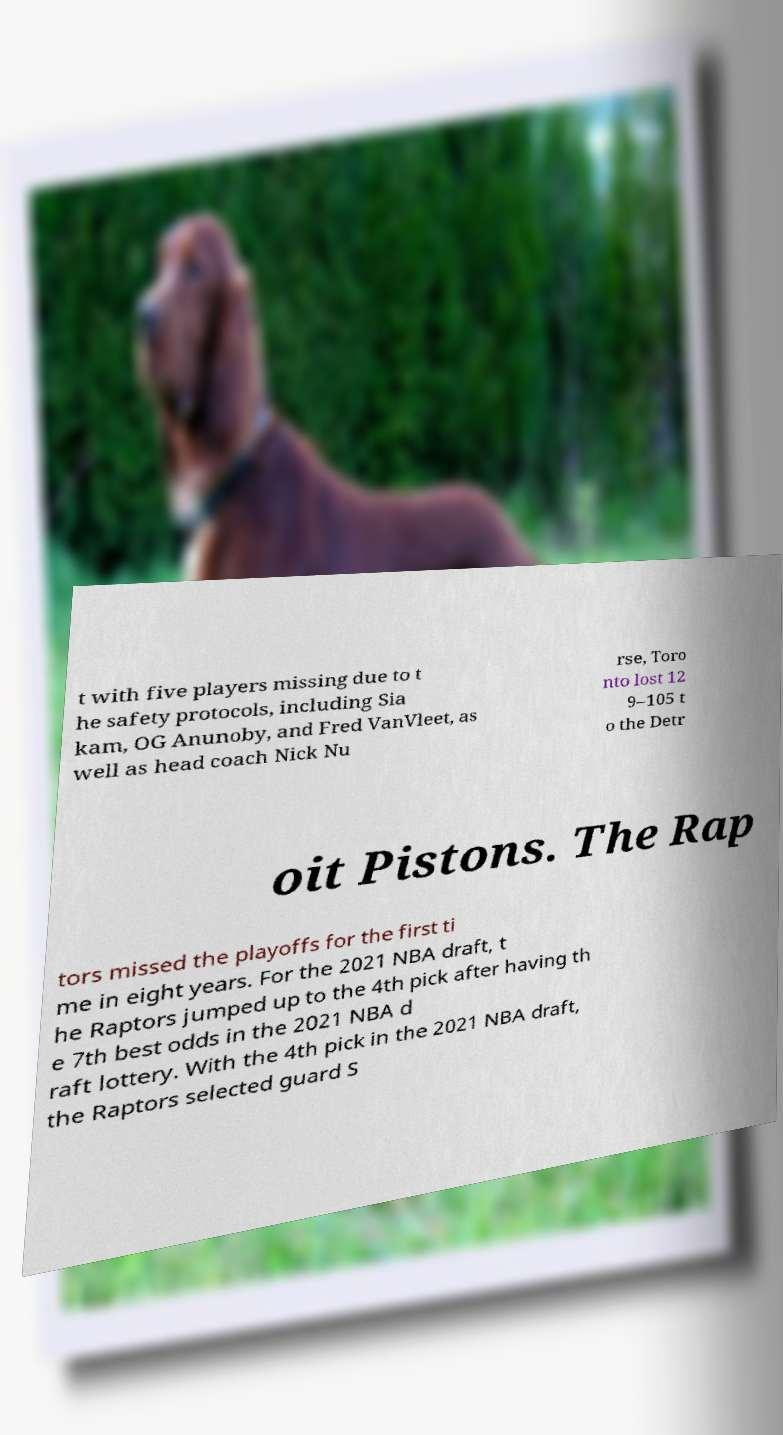Could you assist in decoding the text presented in this image and type it out clearly? t with five players missing due to t he safety protocols, including Sia kam, OG Anunoby, and Fred VanVleet, as well as head coach Nick Nu rse, Toro nto lost 12 9–105 t o the Detr oit Pistons. The Rap tors missed the playoffs for the first ti me in eight years. For the 2021 NBA draft, t he Raptors jumped up to the 4th pick after having th e 7th best odds in the 2021 NBA d raft lottery. With the 4th pick in the 2021 NBA draft, the Raptors selected guard S 